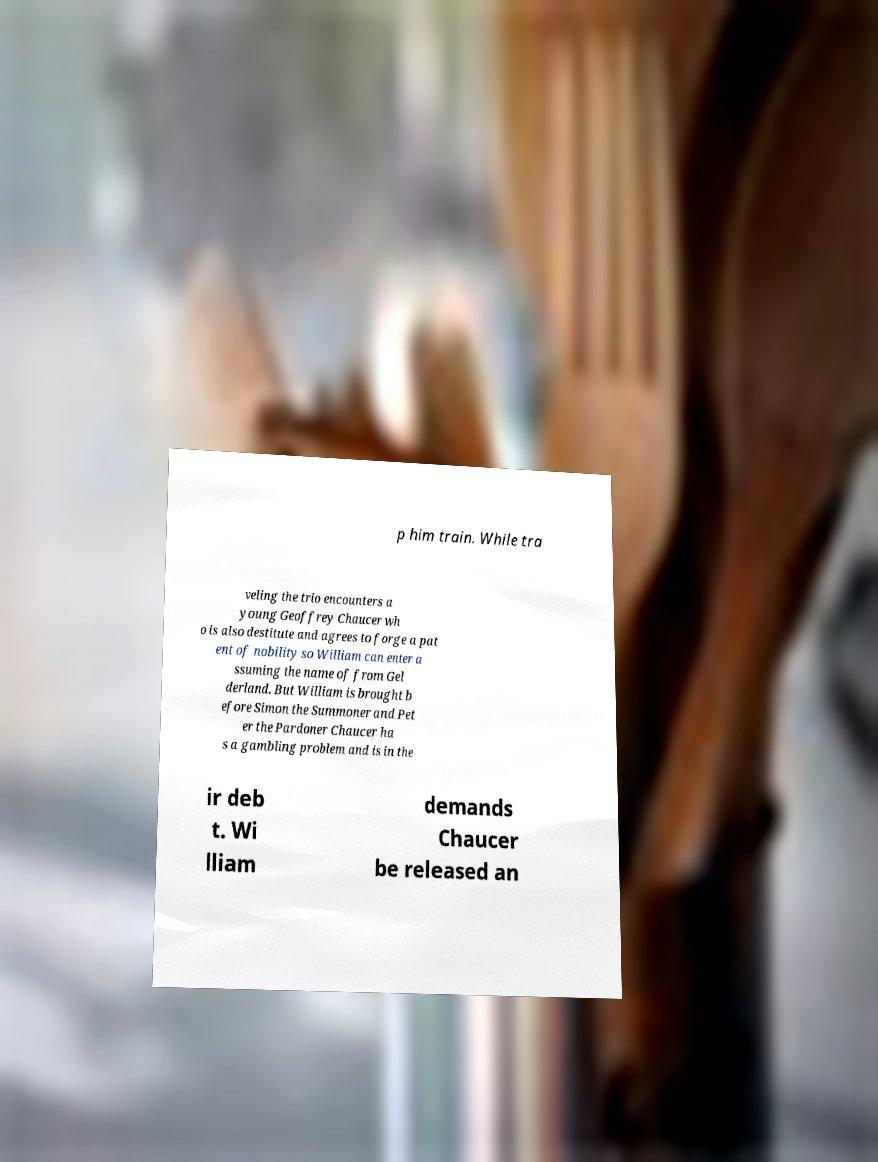Please read and relay the text visible in this image. What does it say? p him train. While tra veling the trio encounters a young Geoffrey Chaucer wh o is also destitute and agrees to forge a pat ent of nobility so William can enter a ssuming the name of from Gel derland. But William is brought b efore Simon the Summoner and Pet er the Pardoner Chaucer ha s a gambling problem and is in the ir deb t. Wi lliam demands Chaucer be released an 